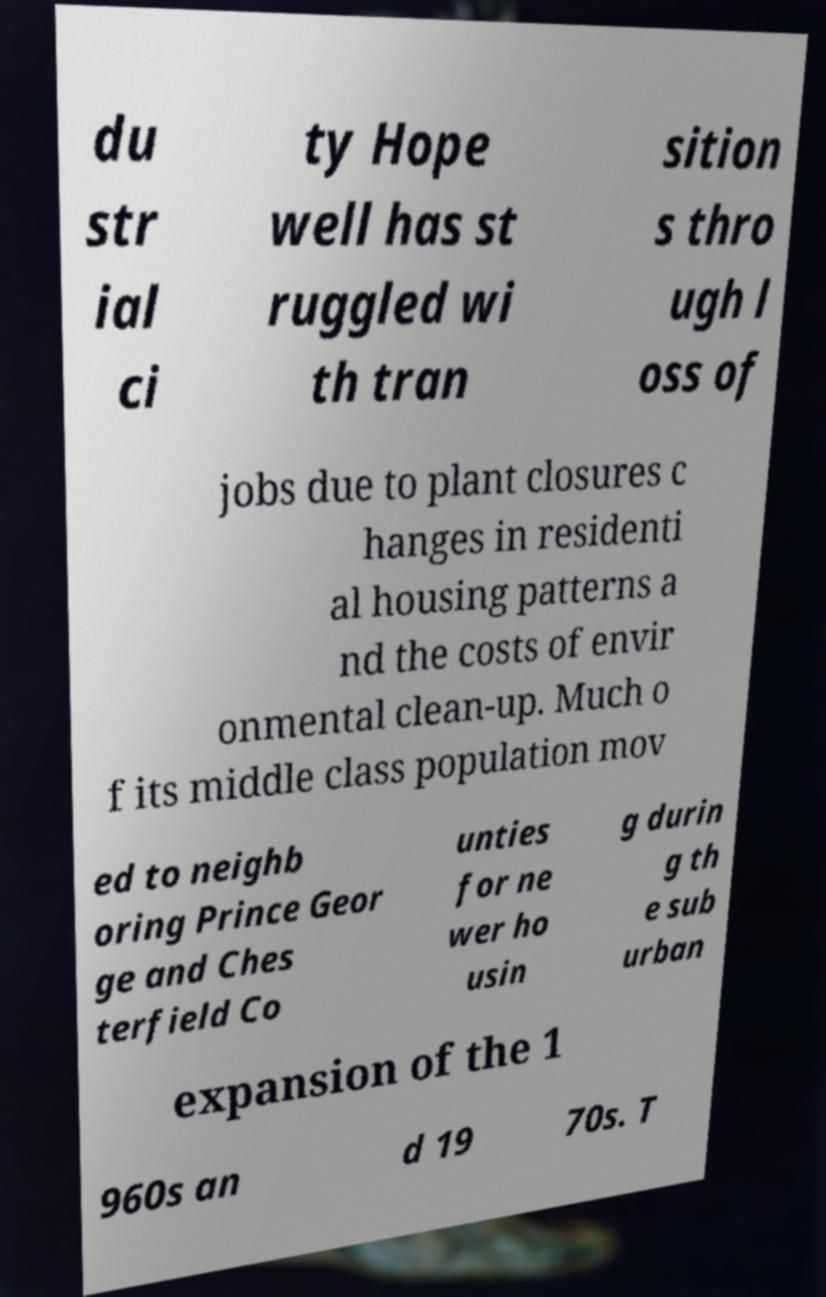For documentation purposes, I need the text within this image transcribed. Could you provide that? du str ial ci ty Hope well has st ruggled wi th tran sition s thro ugh l oss of jobs due to plant closures c hanges in residenti al housing patterns a nd the costs of envir onmental clean-up. Much o f its middle class population mov ed to neighb oring Prince Geor ge and Ches terfield Co unties for ne wer ho usin g durin g th e sub urban expansion of the 1 960s an d 19 70s. T 